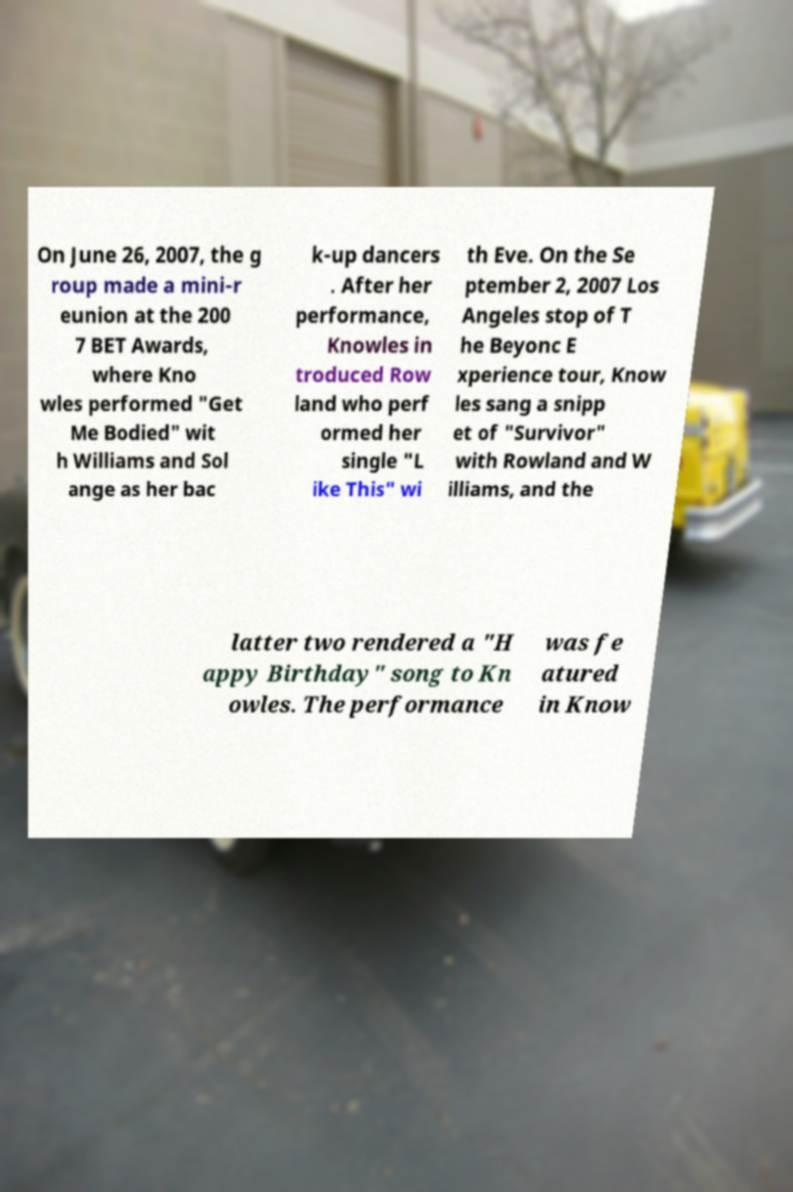For documentation purposes, I need the text within this image transcribed. Could you provide that? On June 26, 2007, the g roup made a mini-r eunion at the 200 7 BET Awards, where Kno wles performed "Get Me Bodied" wit h Williams and Sol ange as her bac k-up dancers . After her performance, Knowles in troduced Row land who perf ormed her single "L ike This" wi th Eve. On the Se ptember 2, 2007 Los Angeles stop of T he Beyonc E xperience tour, Know les sang a snipp et of "Survivor" with Rowland and W illiams, and the latter two rendered a "H appy Birthday" song to Kn owles. The performance was fe atured in Know 